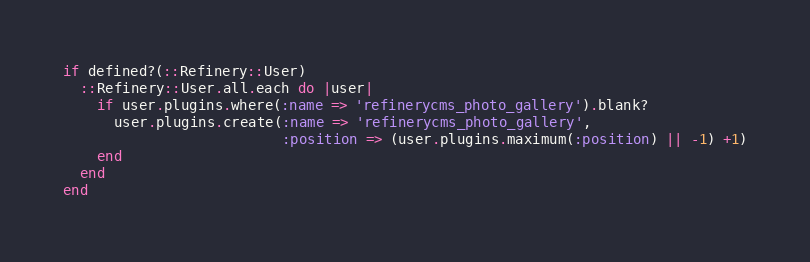Convert code to text. <code><loc_0><loc_0><loc_500><loc_500><_Ruby_>if defined?(::Refinery::User)
  ::Refinery::User.all.each do |user|
    if user.plugins.where(:name => 'refinerycms_photo_gallery').blank?
      user.plugins.create(:name => 'refinerycms_photo_gallery',
                          :position => (user.plugins.maximum(:position) || -1) +1)
    end
  end
end

</code> 